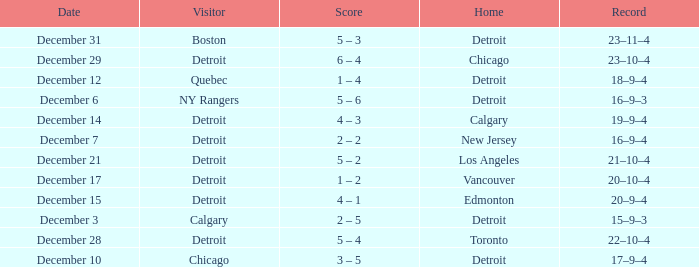On which date is the game being held in detroit with chicago as the visiting side? December 10. 